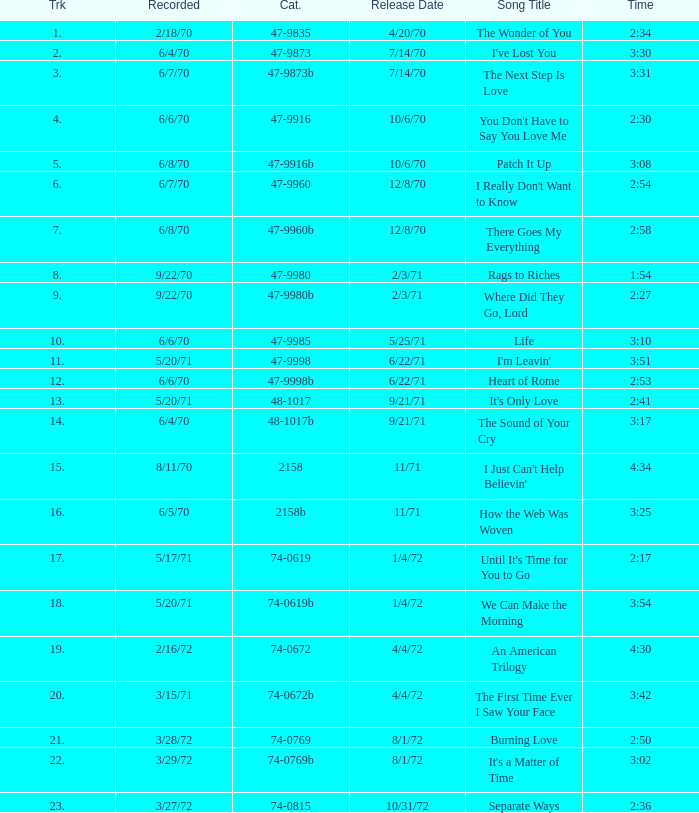What is the highest track for Burning Love? 21.0. 